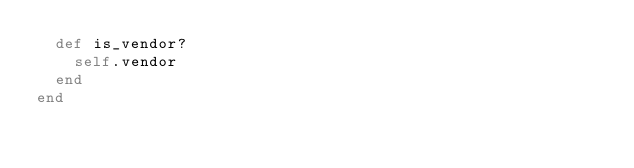Convert code to text. <code><loc_0><loc_0><loc_500><loc_500><_Ruby_>  def is_vendor?
    self.vendor
  end
end
</code> 